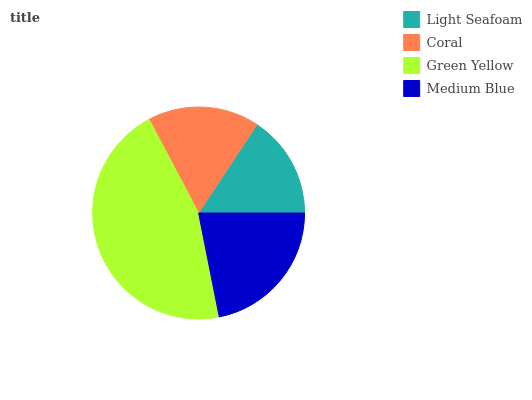Is Light Seafoam the minimum?
Answer yes or no. Yes. Is Green Yellow the maximum?
Answer yes or no. Yes. Is Coral the minimum?
Answer yes or no. No. Is Coral the maximum?
Answer yes or no. No. Is Coral greater than Light Seafoam?
Answer yes or no. Yes. Is Light Seafoam less than Coral?
Answer yes or no. Yes. Is Light Seafoam greater than Coral?
Answer yes or no. No. Is Coral less than Light Seafoam?
Answer yes or no. No. Is Medium Blue the high median?
Answer yes or no. Yes. Is Coral the low median?
Answer yes or no. Yes. Is Green Yellow the high median?
Answer yes or no. No. Is Green Yellow the low median?
Answer yes or no. No. 